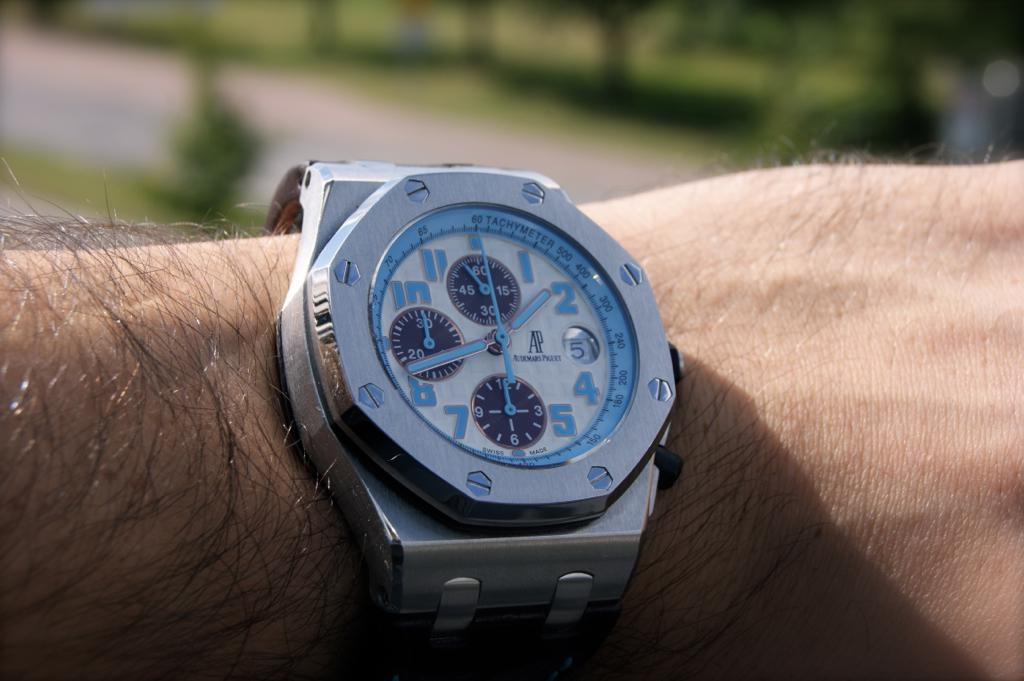What can be seen on the hand in the image? There is a watch on the hand in the image. Can you describe the watch? The watch is blue, white, and silver in color. What is visible in the background of the image? There is a road and trees visible in the background of the image. How are the trees depicted in the image? The trees appear blurry in the background. What type of reaction can be seen from the person during the earthquake in the image? There is no earthquake depicted in the image, and therefore no reaction can be observed. 